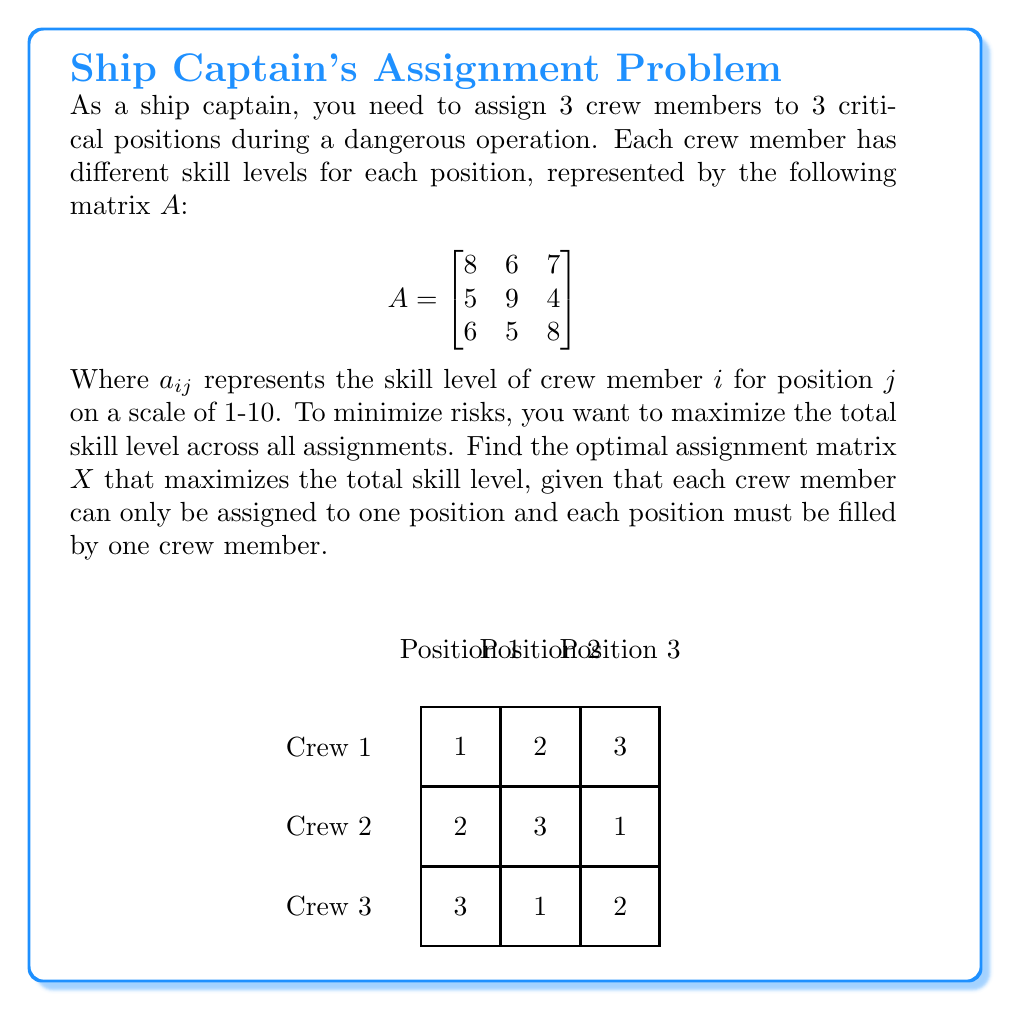Provide a solution to this math problem. To solve this problem, we'll use the Hungarian algorithm, which is an optimization algorithm for assignment problems. Here are the steps:

1) First, we need to convert this maximization problem into a minimization problem. We do this by subtracting each element from the maximum value in the matrix (9):

$$B = \begin{bmatrix}
1 & 3 & 2 \\
4 & 0 & 5 \\
3 & 4 & 1
\end{bmatrix}$$

2) Now we apply the Hungarian algorithm:

   a) Subtract the smallest element in each row from all elements in that row:
   $$\begin{bmatrix}
   0 & 2 & 1 \\
   4 & 0 & 5 \\
   2 & 3 & 0
   \end{bmatrix}$$

   b) Subtract the smallest element in each column from all elements in that column:
   $$\begin{bmatrix}
   0 & 2 & 1 \\
   4 & 0 & 5 \\
   2 & 3 & 0
   \end{bmatrix}$$

   c) Draw lines through rows and columns to cover all zeros with the minimum number of lines:
   
   [asy]
   unitsize(30);
   defaultpen(fontsize(10pt));
   
   for (int i = 0; i < 3; ++i) {
     for (int j = 0; j < 3; ++j) {
       draw(box((j,2-i),(j+1,3-i)));
     }
   }
   
   label("0", (0.5,2.5));
   label("2", (1.5,2.5));
   label("1", (2.5,2.5));
   label("4", (0.5,1.5));
   label("0", (1.5,1.5));
   label("5", (2.5,1.5));
   label("2", (0.5,0.5));
   label("3", (1.5,0.5));
   label("0", (2.5,0.5));
   
   draw((0,3)--(0,0), red);
   draw((1,3)--(1,0), red);
   draw((0,2)--(3,2), red);
   [/asy]

   d) Since we need 3 lines to cover all zeros, we're done. The optimal assignment is where the zeros are located.

3) Translating this back to our original problem, the optimal assignment matrix $X$ is:

$$X = \begin{bmatrix}
1 & 0 & 0 \\
0 & 1 & 0 \\
0 & 0 & 1
\end{bmatrix}$$

This means:
- Crew member 1 is assigned to position 1
- Crew member 2 is assigned to position 2
- Crew member 3 is assigned to position 3

The total skill level for this assignment is: $8 + 9 + 8 = 25$
Answer: $$X = \begin{bmatrix}
1 & 0 & 0 \\
0 & 1 & 0 \\
0 & 0 & 1
\end{bmatrix}$$ 